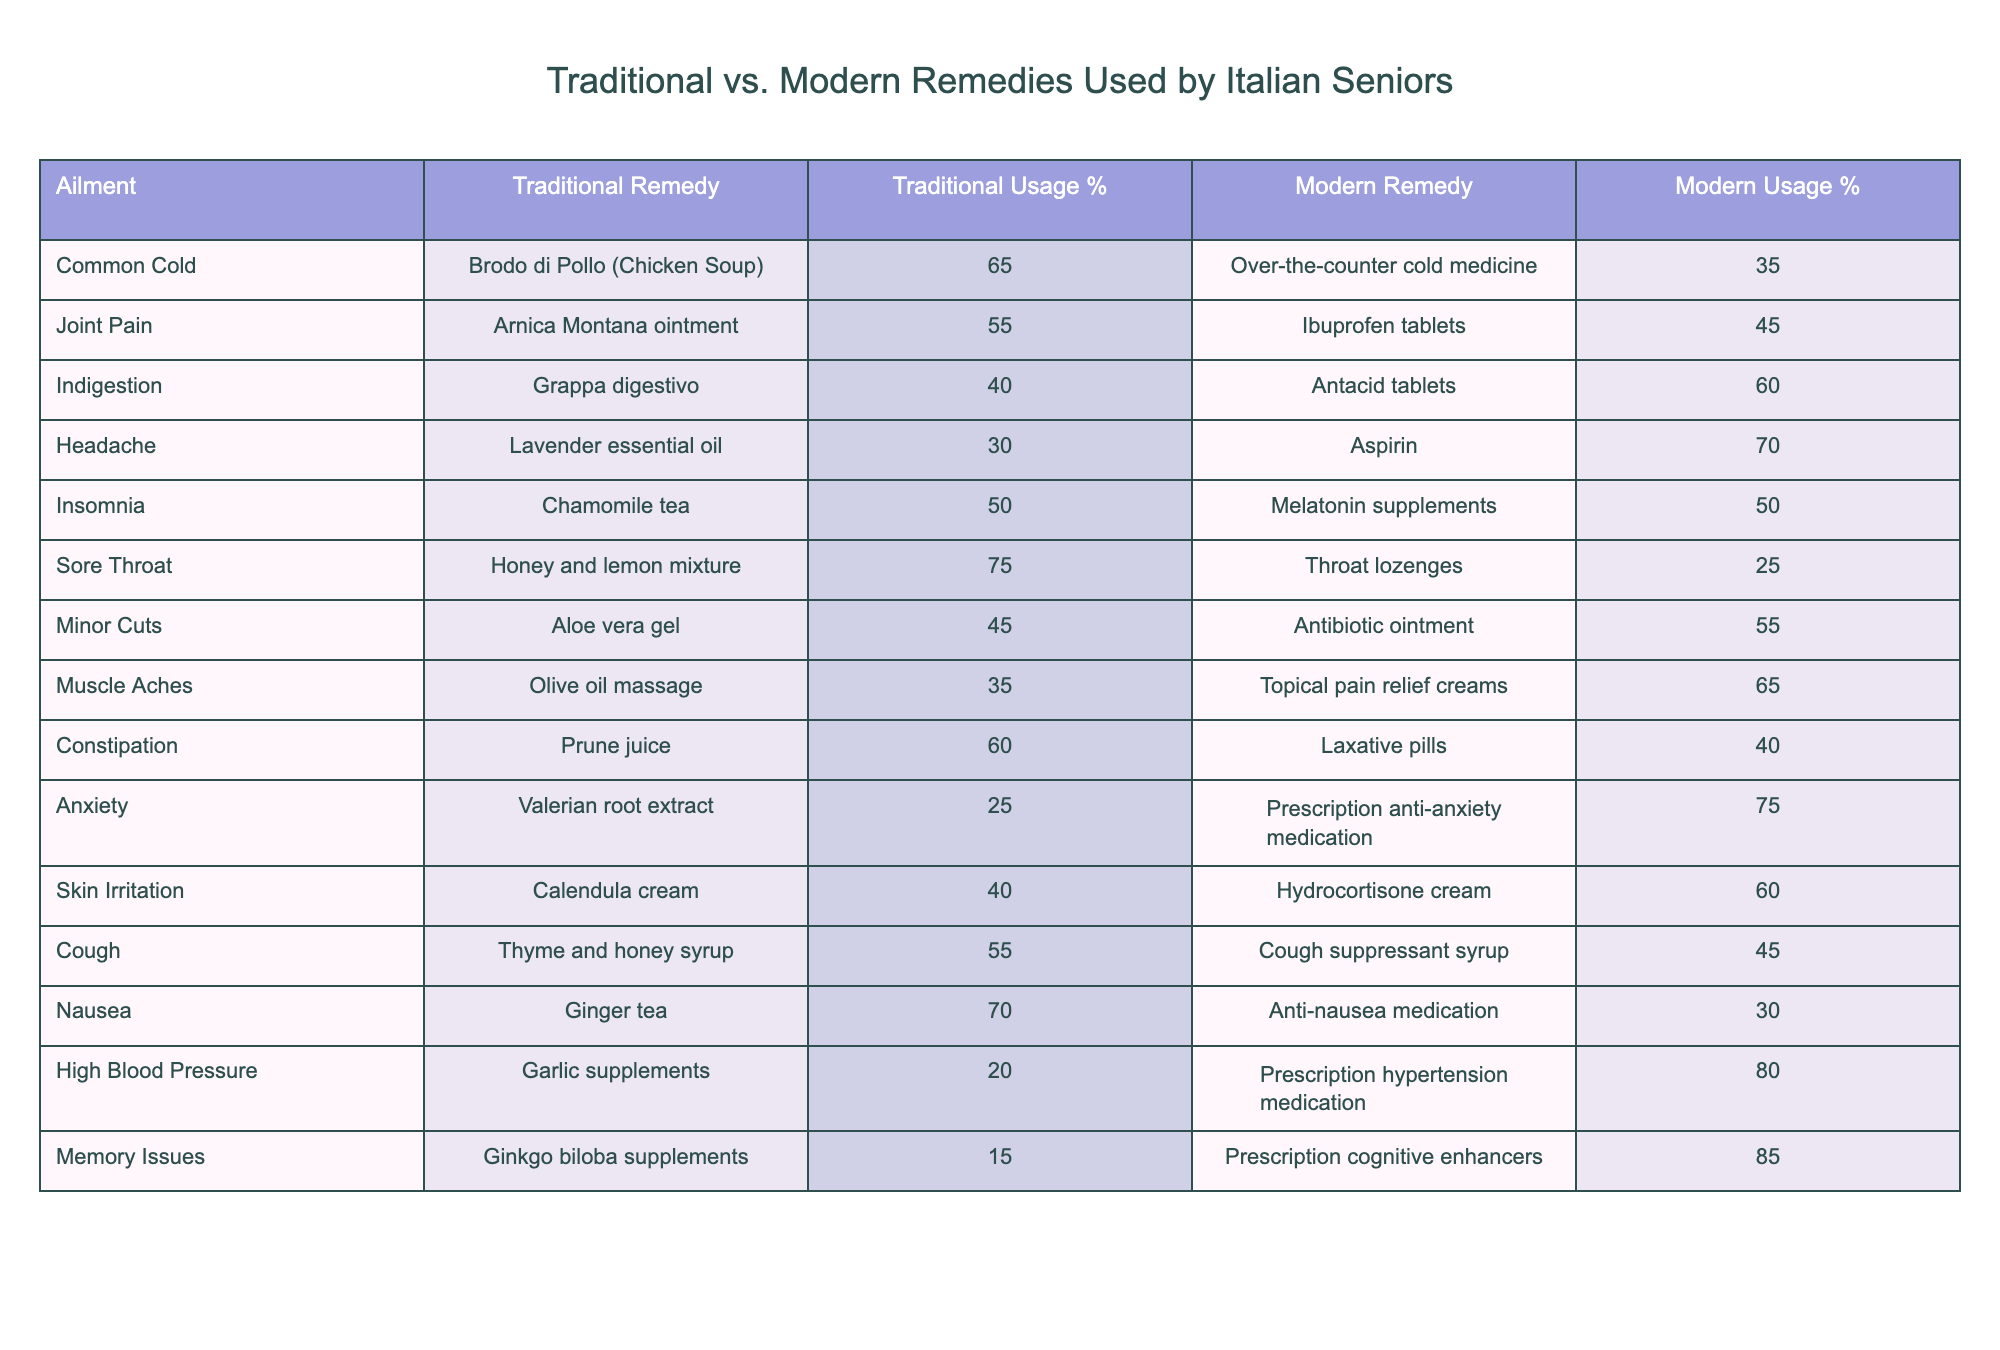What is the traditional remedy for a common cold? The table lists "Brodo di Pollo (Chicken Soup)" as the traditional remedy for a common cold.
Answer: Brodo di Pollo (Chicken Soup) Which modern remedy has the highest usage percentage for joint pain? According to the table, "Ibuprofen tablets" have a 45% usage, which is higher than the 55% for the traditional remedy "Arnica Montana ointment".
Answer: Ibuprofen tablets Is "Chamomile tea" equally used as a traditional and modern remedy for insomnia? Yes, both traditional and modern remedies for insomnia have a usage percentage of 50%, making them equal in this regard.
Answer: Yes What is the traditional remedy with the lowest usage percentage for anxiety? The table shows "Valerian root extract" has the lowest traditional usage percentage for anxiety, which is 25%.
Answer: Valerian root extract How much more frequently is "Aspirin" used compared to "Lavender essential oil" for headaches? "Aspirin" has a usage percentage of 70%, and "Lavender essential oil" has 30%. The difference is 70 - 30 = 40.
Answer: 40% What percentage of seniors utilize traditional remedies for indigestion? The table states that the traditional remedy for indigestion, "Grappa digestivo," is used by 40% of seniors.
Answer: 40% Which ailment has the highest traditional remedy usage percentage? "Sore Throat" has the highest traditional remedy usage percentage at 75%, according to the table.
Answer: Sore Throat If you sum the usage percentages of both remedies for nausea, what do you get? The traditional remedy "Ginger tea" has a usage percentage of 70%, and the modern remedy has 30%. Adding them gives 70 + 30 = 100%.
Answer: 100% Is it true that more seniors prefer modern remedies for muscle aches compared to traditional remedies? Yes, the table shows that 65% prefer modern remedies ("Topical pain relief creams") compared to 35% for the traditional remedy.
Answer: Yes What ailment has the most disparity between traditional and modern remedy usage percentage? "High Blood Pressure" has a difference of 60% between traditional (20%) and modern (80%), which is the largest disparity.
Answer: High Blood Pressure 